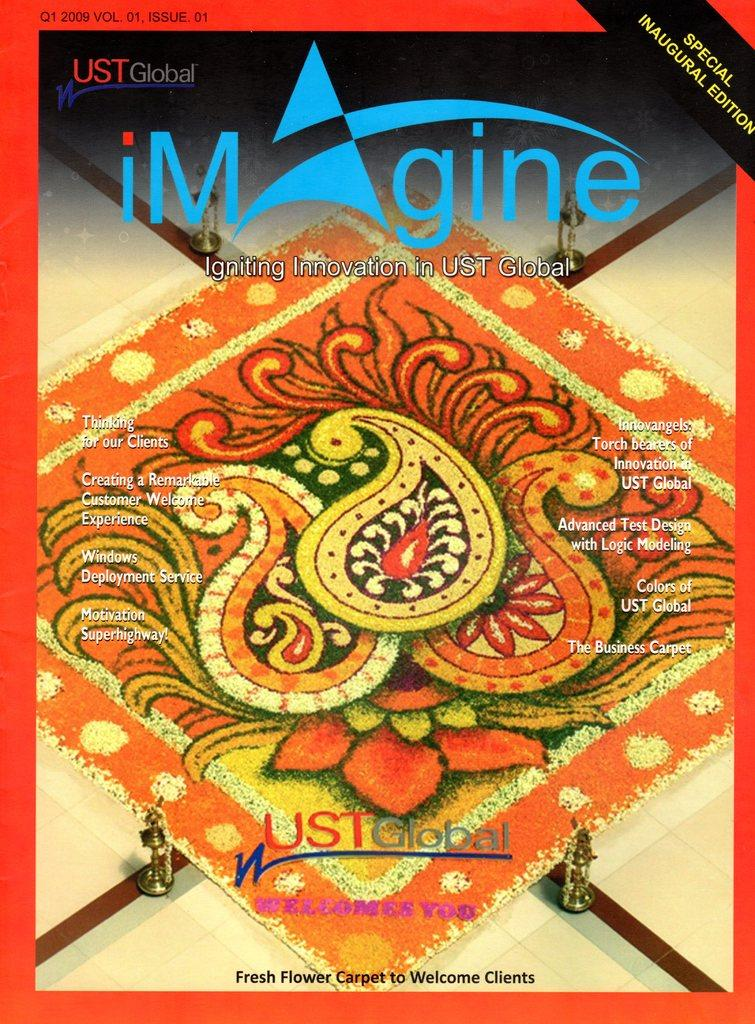Provide a one-sentence caption for the provided image. A magazine cover for a special inaugural edition of the magazine Imagine. 